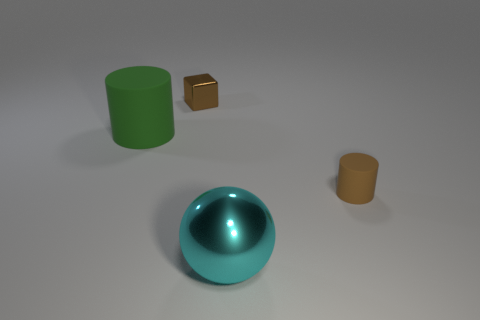Add 2 large yellow shiny blocks. How many objects exist? 6 Subtract all spheres. How many objects are left? 3 Subtract 0 gray cubes. How many objects are left? 4 Subtract all tiny metallic balls. Subtract all tiny brown metal objects. How many objects are left? 3 Add 4 small brown matte cylinders. How many small brown matte cylinders are left? 5 Add 4 tiny shiny cylinders. How many tiny shiny cylinders exist? 4 